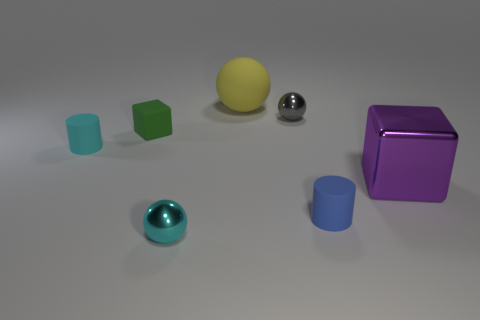The small cyan object in front of the cyan thing that is behind the small cyan object that is in front of the big block is what shape?
Provide a short and direct response. Sphere. What shape is the tiny gray object that is the same material as the cyan ball?
Keep it short and to the point. Sphere. The green rubber thing has what size?
Ensure brevity in your answer.  Small. Does the rubber ball have the same size as the gray metallic ball?
Ensure brevity in your answer.  No. What number of objects are metallic balls in front of the gray shiny object or shiny blocks in front of the small gray metallic object?
Ensure brevity in your answer.  2. There is a small matte cylinder to the left of the tiny gray thing that is to the right of the small green matte object; how many tiny metallic things are right of it?
Your response must be concise. 2. What is the size of the cube that is left of the gray thing?
Provide a succinct answer. Small. How many cylinders have the same size as the cyan matte thing?
Keep it short and to the point. 1. There is a blue thing; does it have the same size as the metallic thing left of the gray metallic thing?
Offer a very short reply. Yes. What number of things are big blue metallic cubes or shiny balls?
Offer a terse response. 2. 